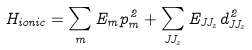Convert formula to latex. <formula><loc_0><loc_0><loc_500><loc_500>H _ { i o n i c } = \sum _ { m } E _ { m } p ^ { 2 } _ { m } + \sum _ { J J _ { z } } E _ { J J _ { z } } d ^ { 2 } _ { J J _ { z } }</formula> 